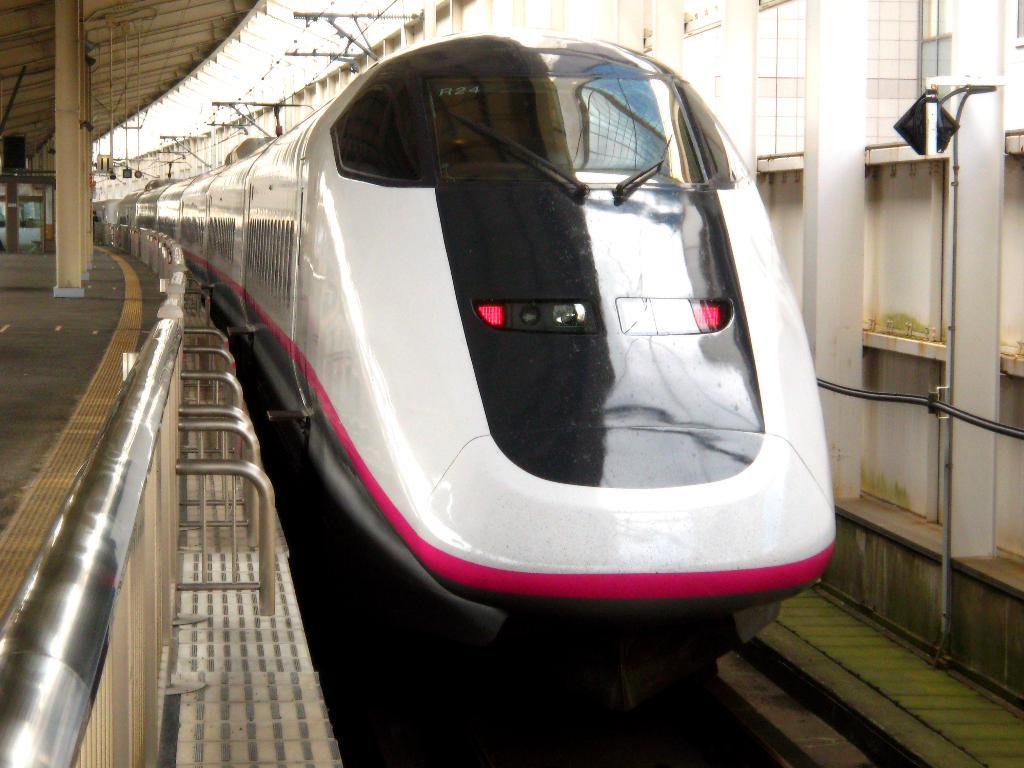What is the main subject of the image? The main subject of the image is a train. Can you describe the setting of the image? In the background of the image, there are buildings. What type of pen is being used to draw the train in the image? There is no pen or drawing in the image; it is a photograph of a real train. Can you see any magic happening with the train in the image? There is no magic or any supernatural elements present in the image; it is a realistic depiction of a train and its surroundings. 